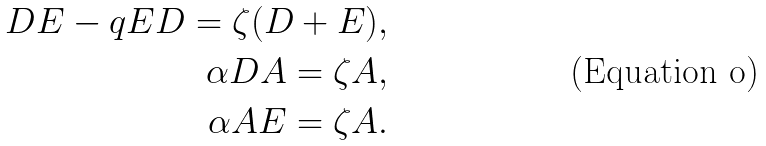<formula> <loc_0><loc_0><loc_500><loc_500>D E - q E D = \zeta ( D + E ) , \\ \alpha D A = \zeta A , \\ \alpha A E = \zeta A .</formula> 